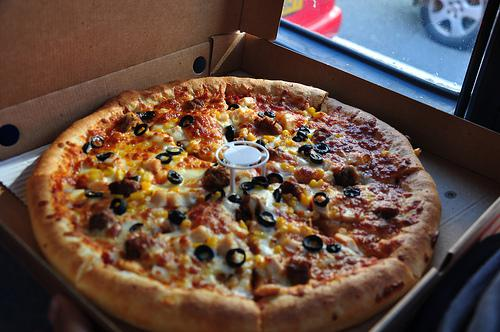Question: what color is the pizza box?
Choices:
A. White.
B. Red.
C. Green.
D. Brown.
Answer with the letter. Answer: D Question: where is the red car?
Choices:
A. By the tracks.
B. By the boat.
C. Outside the window.
D. By the train.
Answer with the letter. Answer: C Question: how pizzas are there?
Choices:
A. Two.
B. Three.
C. One.
D. Four.
Answer with the letter. Answer: C Question: what are the black round toppings on the pizza?
Choices:
A. Peppers.
B. Olives.
C. Onions.
D. Meat.
Answer with the letter. Answer: B 